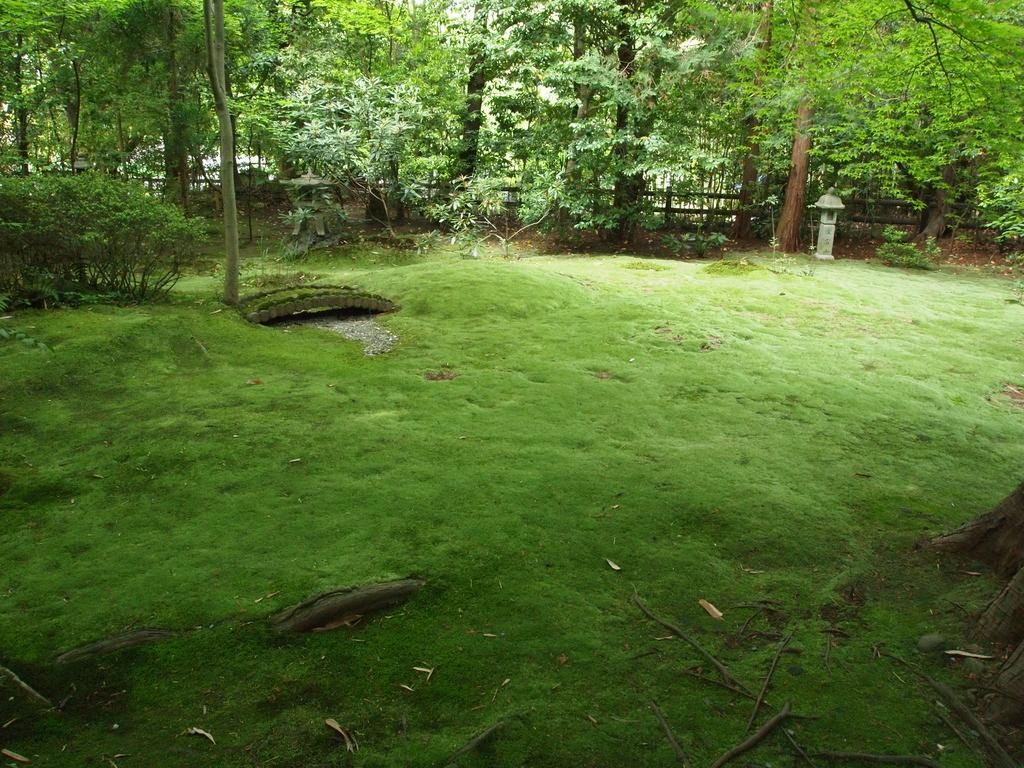What can be seen in the foreground of the picture? In the foreground of the picture, there are twigs, dry leaves, grass, a plant, and the trunk of a tree. There are also other objects present. Can you describe the vegetation in the foreground of the picture? The vegetation in the foreground includes twigs, dry leaves, grass, and a plant. What is visible in the background of the picture? In the background of the picture, there are trees, plants, and a railing. What verse can be heard recited by the plant in the foreground of the picture? There is no verse being recited by the plant in the image, as plants do not have the ability to speak or recite verses. How many bits of information can be gathered from the plant in the foreground of the picture? There is no mention of bits of information in the image, as it focuses on the visual aspects of the scene. 